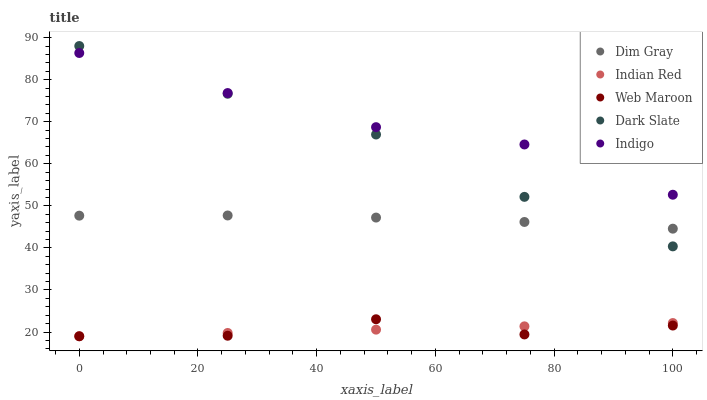Does Web Maroon have the minimum area under the curve?
Answer yes or no. Yes. Does Indigo have the maximum area under the curve?
Answer yes or no. Yes. Does Dim Gray have the minimum area under the curve?
Answer yes or no. No. Does Dim Gray have the maximum area under the curve?
Answer yes or no. No. Is Indian Red the smoothest?
Answer yes or no. Yes. Is Web Maroon the roughest?
Answer yes or no. Yes. Is Dim Gray the smoothest?
Answer yes or no. No. Is Dim Gray the roughest?
Answer yes or no. No. Does Web Maroon have the lowest value?
Answer yes or no. Yes. Does Dim Gray have the lowest value?
Answer yes or no. No. Does Dark Slate have the highest value?
Answer yes or no. Yes. Does Dim Gray have the highest value?
Answer yes or no. No. Is Indian Red less than Dim Gray?
Answer yes or no. Yes. Is Dark Slate greater than Web Maroon?
Answer yes or no. Yes. Does Dark Slate intersect Dim Gray?
Answer yes or no. Yes. Is Dark Slate less than Dim Gray?
Answer yes or no. No. Is Dark Slate greater than Dim Gray?
Answer yes or no. No. Does Indian Red intersect Dim Gray?
Answer yes or no. No. 